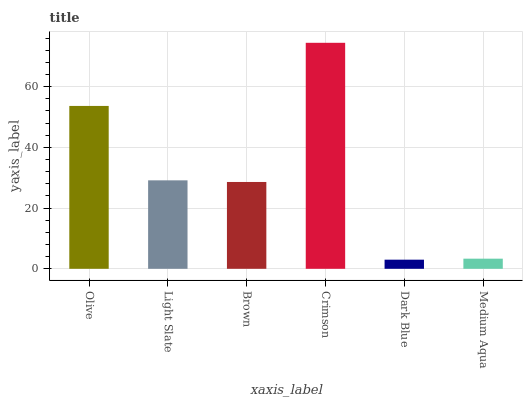Is Light Slate the minimum?
Answer yes or no. No. Is Light Slate the maximum?
Answer yes or no. No. Is Olive greater than Light Slate?
Answer yes or no. Yes. Is Light Slate less than Olive?
Answer yes or no. Yes. Is Light Slate greater than Olive?
Answer yes or no. No. Is Olive less than Light Slate?
Answer yes or no. No. Is Light Slate the high median?
Answer yes or no. Yes. Is Brown the low median?
Answer yes or no. Yes. Is Brown the high median?
Answer yes or no. No. Is Dark Blue the low median?
Answer yes or no. No. 